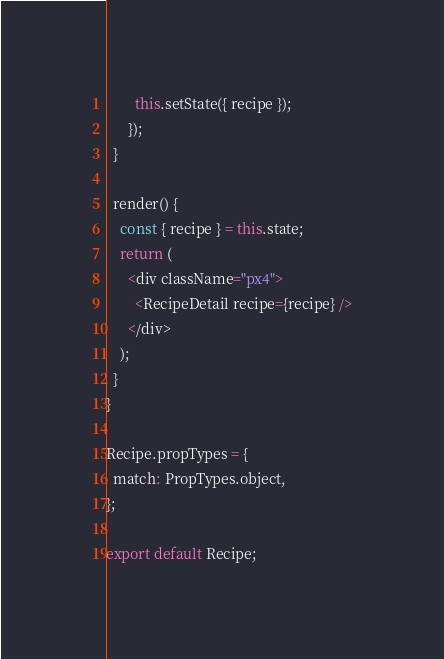<code> <loc_0><loc_0><loc_500><loc_500><_JavaScript_>        this.setState({ recipe });
      });
  }

  render() {
    const { recipe } = this.state;
    return (
      <div className="px4">
        <RecipeDetail recipe={recipe} />
      </div>
    );
  }
}

Recipe.propTypes = {
  match: PropTypes.object,
};

export default Recipe;
</code> 